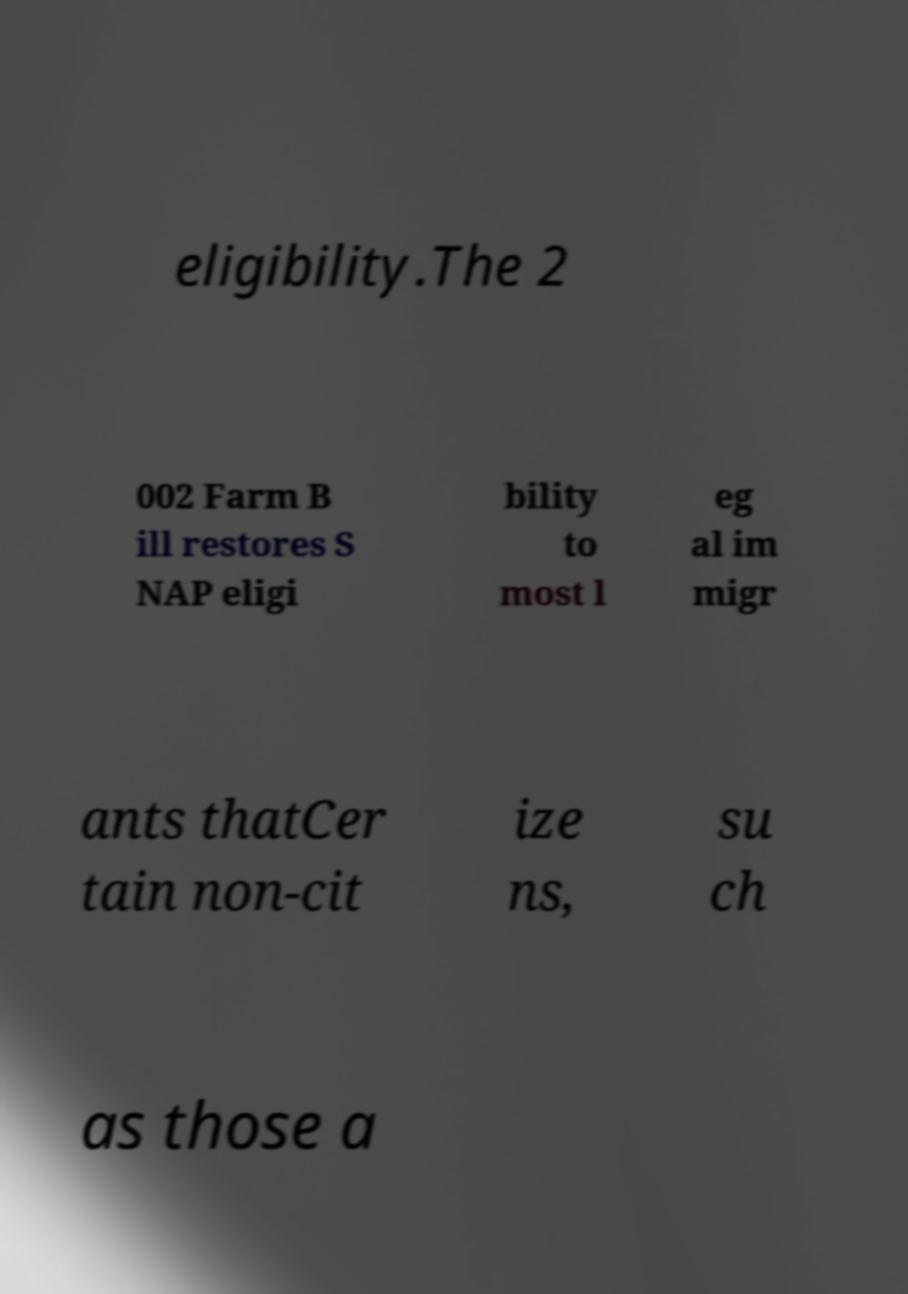For documentation purposes, I need the text within this image transcribed. Could you provide that? eligibility.The 2 002 Farm B ill restores S NAP eligi bility to most l eg al im migr ants thatCer tain non-cit ize ns, su ch as those a 